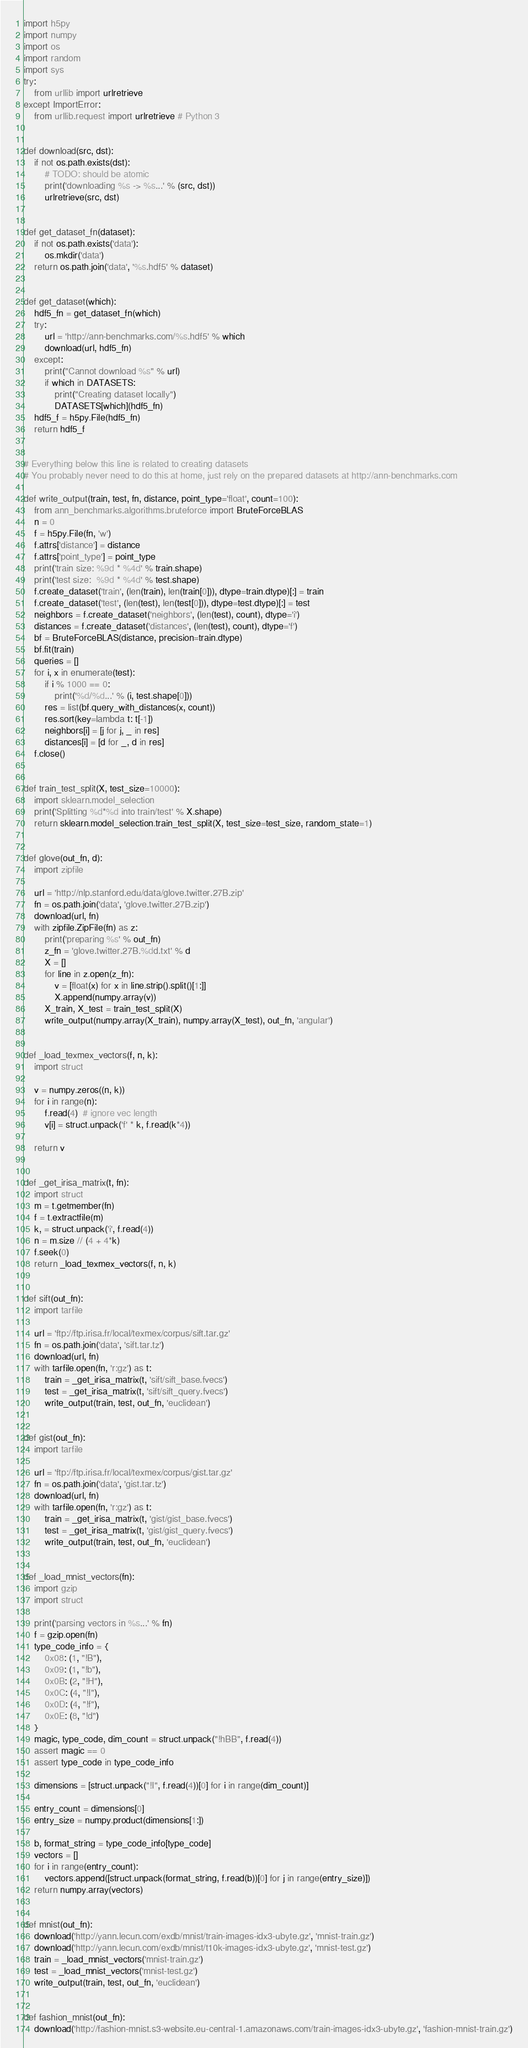Convert code to text. <code><loc_0><loc_0><loc_500><loc_500><_Python_>import h5py
import numpy
import os
import random
import sys
try:
    from urllib import urlretrieve
except ImportError:
    from urllib.request import urlretrieve # Python 3


def download(src, dst):
    if not os.path.exists(dst):
        # TODO: should be atomic
        print('downloading %s -> %s...' % (src, dst))
        urlretrieve(src, dst)


def get_dataset_fn(dataset):
    if not os.path.exists('data'):
        os.mkdir('data')
    return os.path.join('data', '%s.hdf5' % dataset)


def get_dataset(which):
    hdf5_fn = get_dataset_fn(which)
    try:
        url = 'http://ann-benchmarks.com/%s.hdf5' % which
        download(url, hdf5_fn)
    except:
        print("Cannot download %s" % url)
        if which in DATASETS:
            print("Creating dataset locally")
            DATASETS[which](hdf5_fn)
    hdf5_f = h5py.File(hdf5_fn)
    return hdf5_f


# Everything below this line is related to creating datasets
# You probably never need to do this at home, just rely on the prepared datasets at http://ann-benchmarks.com

def write_output(train, test, fn, distance, point_type='float', count=100):
    from ann_benchmarks.algorithms.bruteforce import BruteForceBLAS
    n = 0
    f = h5py.File(fn, 'w')
    f.attrs['distance'] = distance
    f.attrs['point_type'] = point_type
    print('train size: %9d * %4d' % train.shape)
    print('test size:  %9d * %4d' % test.shape)
    f.create_dataset('train', (len(train), len(train[0])), dtype=train.dtype)[:] = train
    f.create_dataset('test', (len(test), len(test[0])), dtype=test.dtype)[:] = test
    neighbors = f.create_dataset('neighbors', (len(test), count), dtype='i')
    distances = f.create_dataset('distances', (len(test), count), dtype='f')
    bf = BruteForceBLAS(distance, precision=train.dtype)
    bf.fit(train)
    queries = []
    for i, x in enumerate(test):
        if i % 1000 == 0:
            print('%d/%d...' % (i, test.shape[0]))
        res = list(bf.query_with_distances(x, count))
        res.sort(key=lambda t: t[-1])
        neighbors[i] = [j for j, _ in res]
        distances[i] = [d for _, d in res]
    f.close()


def train_test_split(X, test_size=10000):
    import sklearn.model_selection
    print('Splitting %d*%d into train/test' % X.shape)
    return sklearn.model_selection.train_test_split(X, test_size=test_size, random_state=1)


def glove(out_fn, d):
    import zipfile

    url = 'http://nlp.stanford.edu/data/glove.twitter.27B.zip'
    fn = os.path.join('data', 'glove.twitter.27B.zip')
    download(url, fn)
    with zipfile.ZipFile(fn) as z:
        print('preparing %s' % out_fn)
        z_fn = 'glove.twitter.27B.%dd.txt' % d
        X = []
        for line in z.open(z_fn):
            v = [float(x) for x in line.strip().split()[1:]]
            X.append(numpy.array(v))
        X_train, X_test = train_test_split(X)
        write_output(numpy.array(X_train), numpy.array(X_test), out_fn, 'angular')


def _load_texmex_vectors(f, n, k):
    import struct

    v = numpy.zeros((n, k))
    for i in range(n):
        f.read(4)  # ignore vec length
        v[i] = struct.unpack('f' * k, f.read(k*4))

    return v


def _get_irisa_matrix(t, fn):
    import struct
    m = t.getmember(fn)
    f = t.extractfile(m)
    k, = struct.unpack('i', f.read(4))
    n = m.size // (4 + 4*k)
    f.seek(0)
    return _load_texmex_vectors(f, n, k)


def sift(out_fn):
    import tarfile

    url = 'ftp://ftp.irisa.fr/local/texmex/corpus/sift.tar.gz'
    fn = os.path.join('data', 'sift.tar.tz')
    download(url, fn)
    with tarfile.open(fn, 'r:gz') as t:
        train = _get_irisa_matrix(t, 'sift/sift_base.fvecs')
        test = _get_irisa_matrix(t, 'sift/sift_query.fvecs')
        write_output(train, test, out_fn, 'euclidean')


def gist(out_fn):
    import tarfile

    url = 'ftp://ftp.irisa.fr/local/texmex/corpus/gist.tar.gz'
    fn = os.path.join('data', 'gist.tar.tz')
    download(url, fn)
    with tarfile.open(fn, 'r:gz') as t:
        train = _get_irisa_matrix(t, 'gist/gist_base.fvecs')
        test = _get_irisa_matrix(t, 'gist/gist_query.fvecs')
        write_output(train, test, out_fn, 'euclidean')


def _load_mnist_vectors(fn):
    import gzip
    import struct

    print('parsing vectors in %s...' % fn)
    f = gzip.open(fn)
    type_code_info = {
        0x08: (1, "!B"),
        0x09: (1, "!b"),
        0x0B: (2, "!H"),
        0x0C: (4, "!I"),
        0x0D: (4, "!f"),
        0x0E: (8, "!d")
    }
    magic, type_code, dim_count = struct.unpack("!hBB", f.read(4))
    assert magic == 0
    assert type_code in type_code_info

    dimensions = [struct.unpack("!I", f.read(4))[0] for i in range(dim_count)]

    entry_count = dimensions[0]
    entry_size = numpy.product(dimensions[1:])

    b, format_string = type_code_info[type_code]
    vectors = []
    for i in range(entry_count):
        vectors.append([struct.unpack(format_string, f.read(b))[0] for j in range(entry_size)])
    return numpy.array(vectors)


def mnist(out_fn):
    download('http://yann.lecun.com/exdb/mnist/train-images-idx3-ubyte.gz', 'mnist-train.gz')
    download('http://yann.lecun.com/exdb/mnist/t10k-images-idx3-ubyte.gz', 'mnist-test.gz')
    train = _load_mnist_vectors('mnist-train.gz')
    test = _load_mnist_vectors('mnist-test.gz')
    write_output(train, test, out_fn, 'euclidean')


def fashion_mnist(out_fn):
    download('http://fashion-mnist.s3-website.eu-central-1.amazonaws.com/train-images-idx3-ubyte.gz', 'fashion-mnist-train.gz')</code> 